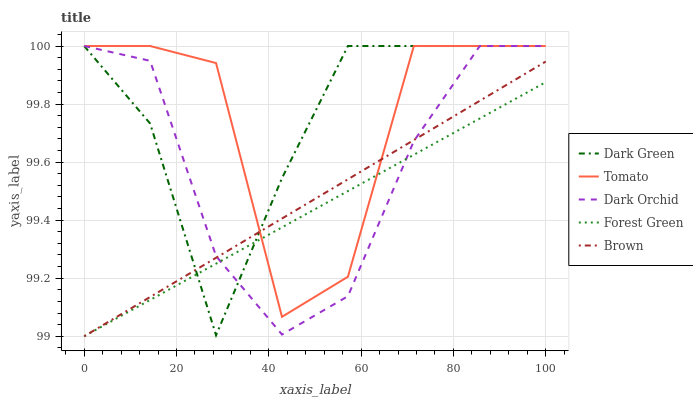Does Forest Green have the minimum area under the curve?
Answer yes or no. Yes. Does Dark Green have the maximum area under the curve?
Answer yes or no. Yes. Does Brown have the minimum area under the curve?
Answer yes or no. No. Does Brown have the maximum area under the curve?
Answer yes or no. No. Is Forest Green the smoothest?
Answer yes or no. Yes. Is Tomato the roughest?
Answer yes or no. Yes. Is Brown the smoothest?
Answer yes or no. No. Is Brown the roughest?
Answer yes or no. No. Does Brown have the lowest value?
Answer yes or no. Yes. Does Dark Orchid have the lowest value?
Answer yes or no. No. Does Dark Green have the highest value?
Answer yes or no. Yes. Does Brown have the highest value?
Answer yes or no. No. Does Forest Green intersect Brown?
Answer yes or no. Yes. Is Forest Green less than Brown?
Answer yes or no. No. Is Forest Green greater than Brown?
Answer yes or no. No. 